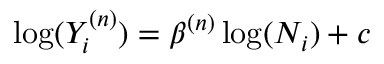<formula> <loc_0><loc_0><loc_500><loc_500>\log ( Y _ { i } ^ { ( n ) } ) = \beta ^ { ( n ) } \log ( N _ { i } ) + c</formula> 